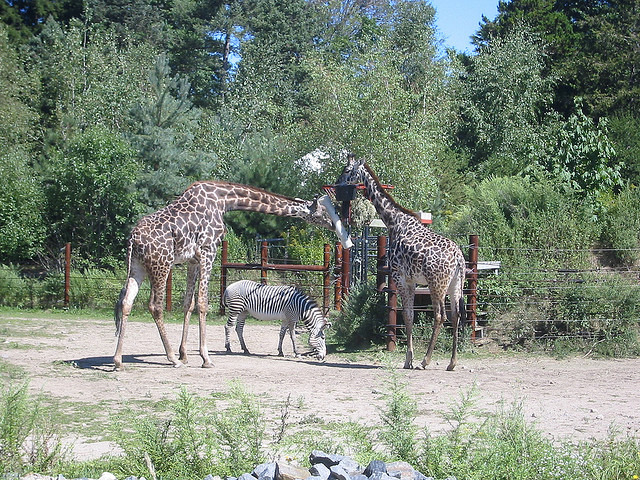What animal is between the giraffes?
A. cow
B. zebra
C. salamander
D. goose
Answer with the option's letter from the given choices directly. B What animal is between the giraffes?
A. zebra
B. cow
C. dog
D. cat A 